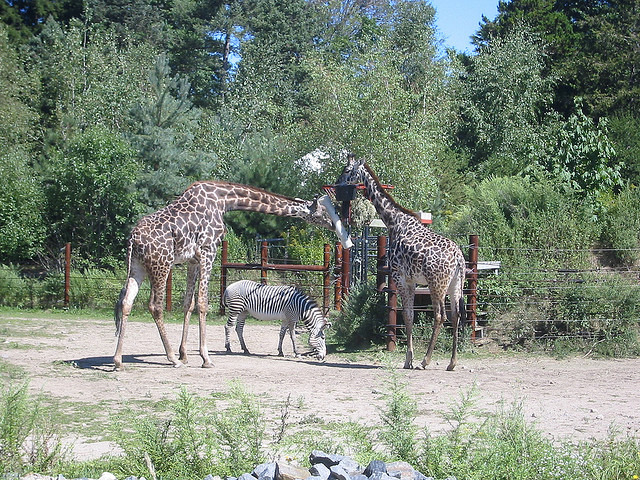What animal is between the giraffes?
A. cow
B. zebra
C. salamander
D. goose
Answer with the option's letter from the given choices directly. B What animal is between the giraffes?
A. zebra
B. cow
C. dog
D. cat A 